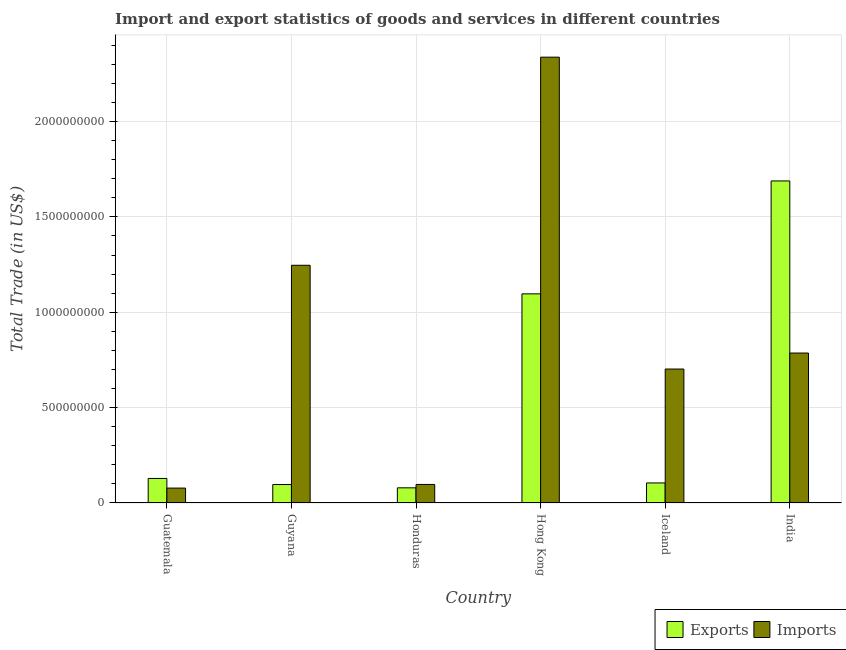Are the number of bars per tick equal to the number of legend labels?
Provide a succinct answer. Yes. Are the number of bars on each tick of the X-axis equal?
Provide a short and direct response. Yes. How many bars are there on the 5th tick from the left?
Give a very brief answer. 2. How many bars are there on the 4th tick from the right?
Keep it short and to the point. 2. What is the label of the 4th group of bars from the left?
Make the answer very short. Hong Kong. In how many cases, is the number of bars for a given country not equal to the number of legend labels?
Keep it short and to the point. 0. What is the export of goods and services in Iceland?
Your answer should be compact. 1.05e+08. Across all countries, what is the maximum export of goods and services?
Your answer should be compact. 1.69e+09. Across all countries, what is the minimum export of goods and services?
Your answer should be compact. 7.95e+07. In which country was the imports of goods and services maximum?
Offer a very short reply. Hong Kong. In which country was the imports of goods and services minimum?
Your response must be concise. Guatemala. What is the total imports of goods and services in the graph?
Provide a short and direct response. 5.25e+09. What is the difference between the export of goods and services in Honduras and that in Hong Kong?
Offer a terse response. -1.02e+09. What is the difference between the imports of goods and services in Guyana and the export of goods and services in Hong Kong?
Your answer should be very brief. 1.50e+08. What is the average export of goods and services per country?
Your response must be concise. 5.32e+08. What is the difference between the export of goods and services and imports of goods and services in Iceland?
Make the answer very short. -5.97e+08. In how many countries, is the export of goods and services greater than 200000000 US$?
Provide a short and direct response. 2. What is the ratio of the export of goods and services in Guyana to that in Iceland?
Provide a succinct answer. 0.92. What is the difference between the highest and the second highest export of goods and services?
Your answer should be compact. 5.92e+08. What is the difference between the highest and the lowest export of goods and services?
Ensure brevity in your answer.  1.61e+09. Is the sum of the imports of goods and services in Guatemala and Hong Kong greater than the maximum export of goods and services across all countries?
Your answer should be very brief. Yes. What does the 1st bar from the left in India represents?
Your answer should be compact. Exports. What does the 1st bar from the right in Hong Kong represents?
Ensure brevity in your answer.  Imports. How many bars are there?
Your response must be concise. 12. What is the difference between two consecutive major ticks on the Y-axis?
Ensure brevity in your answer.  5.00e+08. Does the graph contain grids?
Provide a short and direct response. Yes. Where does the legend appear in the graph?
Your answer should be very brief. Bottom right. How many legend labels are there?
Your answer should be very brief. 2. How are the legend labels stacked?
Give a very brief answer. Horizontal. What is the title of the graph?
Provide a succinct answer. Import and export statistics of goods and services in different countries. What is the label or title of the Y-axis?
Provide a short and direct response. Total Trade (in US$). What is the Total Trade (in US$) in Exports in Guatemala?
Offer a terse response. 1.29e+08. What is the Total Trade (in US$) of Imports in Guatemala?
Make the answer very short. 7.81e+07. What is the Total Trade (in US$) in Exports in Guyana?
Make the answer very short. 9.68e+07. What is the Total Trade (in US$) in Imports in Guyana?
Give a very brief answer. 1.25e+09. What is the Total Trade (in US$) of Exports in Honduras?
Make the answer very short. 7.95e+07. What is the Total Trade (in US$) of Imports in Honduras?
Offer a very short reply. 9.72e+07. What is the Total Trade (in US$) of Exports in Hong Kong?
Your answer should be compact. 1.10e+09. What is the Total Trade (in US$) in Imports in Hong Kong?
Provide a short and direct response. 2.34e+09. What is the Total Trade (in US$) of Exports in Iceland?
Make the answer very short. 1.05e+08. What is the Total Trade (in US$) in Imports in Iceland?
Offer a very short reply. 7.02e+08. What is the Total Trade (in US$) in Exports in India?
Provide a short and direct response. 1.69e+09. What is the Total Trade (in US$) in Imports in India?
Provide a short and direct response. 7.86e+08. Across all countries, what is the maximum Total Trade (in US$) of Exports?
Your answer should be very brief. 1.69e+09. Across all countries, what is the maximum Total Trade (in US$) of Imports?
Your answer should be compact. 2.34e+09. Across all countries, what is the minimum Total Trade (in US$) of Exports?
Your response must be concise. 7.95e+07. Across all countries, what is the minimum Total Trade (in US$) in Imports?
Your answer should be very brief. 7.81e+07. What is the total Total Trade (in US$) of Exports in the graph?
Offer a terse response. 3.19e+09. What is the total Total Trade (in US$) in Imports in the graph?
Provide a short and direct response. 5.25e+09. What is the difference between the Total Trade (in US$) in Exports in Guatemala and that in Guyana?
Offer a very short reply. 3.19e+07. What is the difference between the Total Trade (in US$) of Imports in Guatemala and that in Guyana?
Provide a succinct answer. -1.17e+09. What is the difference between the Total Trade (in US$) in Exports in Guatemala and that in Honduras?
Keep it short and to the point. 4.92e+07. What is the difference between the Total Trade (in US$) of Imports in Guatemala and that in Honduras?
Offer a terse response. -1.91e+07. What is the difference between the Total Trade (in US$) of Exports in Guatemala and that in Hong Kong?
Keep it short and to the point. -9.68e+08. What is the difference between the Total Trade (in US$) in Imports in Guatemala and that in Hong Kong?
Offer a very short reply. -2.26e+09. What is the difference between the Total Trade (in US$) in Exports in Guatemala and that in Iceland?
Keep it short and to the point. 2.36e+07. What is the difference between the Total Trade (in US$) in Imports in Guatemala and that in Iceland?
Your answer should be compact. -6.24e+08. What is the difference between the Total Trade (in US$) of Exports in Guatemala and that in India?
Your answer should be very brief. -1.56e+09. What is the difference between the Total Trade (in US$) in Imports in Guatemala and that in India?
Your answer should be very brief. -7.08e+08. What is the difference between the Total Trade (in US$) of Exports in Guyana and that in Honduras?
Offer a terse response. 1.73e+07. What is the difference between the Total Trade (in US$) in Imports in Guyana and that in Honduras?
Ensure brevity in your answer.  1.15e+09. What is the difference between the Total Trade (in US$) of Exports in Guyana and that in Hong Kong?
Ensure brevity in your answer.  -1.00e+09. What is the difference between the Total Trade (in US$) of Imports in Guyana and that in Hong Kong?
Your answer should be compact. -1.09e+09. What is the difference between the Total Trade (in US$) in Exports in Guyana and that in Iceland?
Give a very brief answer. -8.34e+06. What is the difference between the Total Trade (in US$) in Imports in Guyana and that in Iceland?
Ensure brevity in your answer.  5.44e+08. What is the difference between the Total Trade (in US$) in Exports in Guyana and that in India?
Keep it short and to the point. -1.59e+09. What is the difference between the Total Trade (in US$) of Imports in Guyana and that in India?
Your answer should be compact. 4.60e+08. What is the difference between the Total Trade (in US$) in Exports in Honduras and that in Hong Kong?
Keep it short and to the point. -1.02e+09. What is the difference between the Total Trade (in US$) of Imports in Honduras and that in Hong Kong?
Offer a very short reply. -2.24e+09. What is the difference between the Total Trade (in US$) of Exports in Honduras and that in Iceland?
Keep it short and to the point. -2.56e+07. What is the difference between the Total Trade (in US$) of Imports in Honduras and that in Iceland?
Make the answer very short. -6.05e+08. What is the difference between the Total Trade (in US$) in Exports in Honduras and that in India?
Offer a terse response. -1.61e+09. What is the difference between the Total Trade (in US$) of Imports in Honduras and that in India?
Your answer should be very brief. -6.89e+08. What is the difference between the Total Trade (in US$) in Exports in Hong Kong and that in Iceland?
Provide a succinct answer. 9.91e+08. What is the difference between the Total Trade (in US$) of Imports in Hong Kong and that in Iceland?
Your answer should be very brief. 1.64e+09. What is the difference between the Total Trade (in US$) in Exports in Hong Kong and that in India?
Ensure brevity in your answer.  -5.92e+08. What is the difference between the Total Trade (in US$) in Imports in Hong Kong and that in India?
Your answer should be compact. 1.55e+09. What is the difference between the Total Trade (in US$) of Exports in Iceland and that in India?
Your answer should be compact. -1.58e+09. What is the difference between the Total Trade (in US$) in Imports in Iceland and that in India?
Make the answer very short. -8.39e+07. What is the difference between the Total Trade (in US$) of Exports in Guatemala and the Total Trade (in US$) of Imports in Guyana?
Offer a very short reply. -1.12e+09. What is the difference between the Total Trade (in US$) of Exports in Guatemala and the Total Trade (in US$) of Imports in Honduras?
Keep it short and to the point. 3.15e+07. What is the difference between the Total Trade (in US$) in Exports in Guatemala and the Total Trade (in US$) in Imports in Hong Kong?
Make the answer very short. -2.21e+09. What is the difference between the Total Trade (in US$) in Exports in Guatemala and the Total Trade (in US$) in Imports in Iceland?
Your answer should be very brief. -5.74e+08. What is the difference between the Total Trade (in US$) in Exports in Guatemala and the Total Trade (in US$) in Imports in India?
Offer a very short reply. -6.57e+08. What is the difference between the Total Trade (in US$) of Exports in Guyana and the Total Trade (in US$) of Imports in Honduras?
Provide a short and direct response. -4.20e+05. What is the difference between the Total Trade (in US$) in Exports in Guyana and the Total Trade (in US$) in Imports in Hong Kong?
Offer a terse response. -2.24e+09. What is the difference between the Total Trade (in US$) in Exports in Guyana and the Total Trade (in US$) in Imports in Iceland?
Your answer should be compact. -6.05e+08. What is the difference between the Total Trade (in US$) of Exports in Guyana and the Total Trade (in US$) of Imports in India?
Offer a terse response. -6.89e+08. What is the difference between the Total Trade (in US$) of Exports in Honduras and the Total Trade (in US$) of Imports in Hong Kong?
Your answer should be compact. -2.26e+09. What is the difference between the Total Trade (in US$) of Exports in Honduras and the Total Trade (in US$) of Imports in Iceland?
Your response must be concise. -6.23e+08. What is the difference between the Total Trade (in US$) of Exports in Honduras and the Total Trade (in US$) of Imports in India?
Your answer should be very brief. -7.07e+08. What is the difference between the Total Trade (in US$) in Exports in Hong Kong and the Total Trade (in US$) in Imports in Iceland?
Your response must be concise. 3.94e+08. What is the difference between the Total Trade (in US$) in Exports in Hong Kong and the Total Trade (in US$) in Imports in India?
Offer a terse response. 3.10e+08. What is the difference between the Total Trade (in US$) of Exports in Iceland and the Total Trade (in US$) of Imports in India?
Your answer should be very brief. -6.81e+08. What is the average Total Trade (in US$) in Exports per country?
Your answer should be compact. 5.32e+08. What is the average Total Trade (in US$) in Imports per country?
Ensure brevity in your answer.  8.75e+08. What is the difference between the Total Trade (in US$) in Exports and Total Trade (in US$) in Imports in Guatemala?
Your answer should be very brief. 5.06e+07. What is the difference between the Total Trade (in US$) of Exports and Total Trade (in US$) of Imports in Guyana?
Provide a short and direct response. -1.15e+09. What is the difference between the Total Trade (in US$) of Exports and Total Trade (in US$) of Imports in Honduras?
Make the answer very short. -1.77e+07. What is the difference between the Total Trade (in US$) of Exports and Total Trade (in US$) of Imports in Hong Kong?
Ensure brevity in your answer.  -1.24e+09. What is the difference between the Total Trade (in US$) of Exports and Total Trade (in US$) of Imports in Iceland?
Give a very brief answer. -5.97e+08. What is the difference between the Total Trade (in US$) in Exports and Total Trade (in US$) in Imports in India?
Make the answer very short. 9.02e+08. What is the ratio of the Total Trade (in US$) of Exports in Guatemala to that in Guyana?
Your response must be concise. 1.33. What is the ratio of the Total Trade (in US$) of Imports in Guatemala to that in Guyana?
Give a very brief answer. 0.06. What is the ratio of the Total Trade (in US$) of Exports in Guatemala to that in Honduras?
Make the answer very short. 1.62. What is the ratio of the Total Trade (in US$) in Imports in Guatemala to that in Honduras?
Ensure brevity in your answer.  0.8. What is the ratio of the Total Trade (in US$) in Exports in Guatemala to that in Hong Kong?
Your response must be concise. 0.12. What is the ratio of the Total Trade (in US$) of Imports in Guatemala to that in Hong Kong?
Make the answer very short. 0.03. What is the ratio of the Total Trade (in US$) in Exports in Guatemala to that in Iceland?
Give a very brief answer. 1.22. What is the ratio of the Total Trade (in US$) in Imports in Guatemala to that in Iceland?
Ensure brevity in your answer.  0.11. What is the ratio of the Total Trade (in US$) in Exports in Guatemala to that in India?
Give a very brief answer. 0.08. What is the ratio of the Total Trade (in US$) of Imports in Guatemala to that in India?
Your answer should be compact. 0.1. What is the ratio of the Total Trade (in US$) of Exports in Guyana to that in Honduras?
Your response must be concise. 1.22. What is the ratio of the Total Trade (in US$) of Imports in Guyana to that in Honduras?
Ensure brevity in your answer.  12.82. What is the ratio of the Total Trade (in US$) of Exports in Guyana to that in Hong Kong?
Provide a succinct answer. 0.09. What is the ratio of the Total Trade (in US$) of Imports in Guyana to that in Hong Kong?
Offer a very short reply. 0.53. What is the ratio of the Total Trade (in US$) of Exports in Guyana to that in Iceland?
Your answer should be very brief. 0.92. What is the ratio of the Total Trade (in US$) of Imports in Guyana to that in Iceland?
Your answer should be compact. 1.77. What is the ratio of the Total Trade (in US$) in Exports in Guyana to that in India?
Offer a terse response. 0.06. What is the ratio of the Total Trade (in US$) in Imports in Guyana to that in India?
Offer a very short reply. 1.59. What is the ratio of the Total Trade (in US$) in Exports in Honduras to that in Hong Kong?
Ensure brevity in your answer.  0.07. What is the ratio of the Total Trade (in US$) of Imports in Honduras to that in Hong Kong?
Keep it short and to the point. 0.04. What is the ratio of the Total Trade (in US$) in Exports in Honduras to that in Iceland?
Provide a short and direct response. 0.76. What is the ratio of the Total Trade (in US$) of Imports in Honduras to that in Iceland?
Provide a short and direct response. 0.14. What is the ratio of the Total Trade (in US$) of Exports in Honduras to that in India?
Make the answer very short. 0.05. What is the ratio of the Total Trade (in US$) in Imports in Honduras to that in India?
Your response must be concise. 0.12. What is the ratio of the Total Trade (in US$) of Exports in Hong Kong to that in Iceland?
Your answer should be compact. 10.43. What is the ratio of the Total Trade (in US$) in Imports in Hong Kong to that in Iceland?
Offer a terse response. 3.33. What is the ratio of the Total Trade (in US$) of Exports in Hong Kong to that in India?
Offer a very short reply. 0.65. What is the ratio of the Total Trade (in US$) in Imports in Hong Kong to that in India?
Ensure brevity in your answer.  2.97. What is the ratio of the Total Trade (in US$) of Exports in Iceland to that in India?
Your answer should be compact. 0.06. What is the ratio of the Total Trade (in US$) of Imports in Iceland to that in India?
Your response must be concise. 0.89. What is the difference between the highest and the second highest Total Trade (in US$) in Exports?
Ensure brevity in your answer.  5.92e+08. What is the difference between the highest and the second highest Total Trade (in US$) of Imports?
Your answer should be very brief. 1.09e+09. What is the difference between the highest and the lowest Total Trade (in US$) in Exports?
Make the answer very short. 1.61e+09. What is the difference between the highest and the lowest Total Trade (in US$) in Imports?
Your answer should be compact. 2.26e+09. 